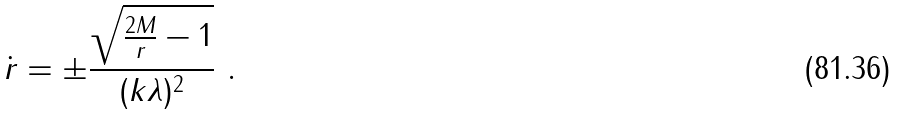Convert formula to latex. <formula><loc_0><loc_0><loc_500><loc_500>\dot { r } = \pm \frac { \sqrt { \frac { 2 M } { r } - 1 } } { ( k \lambda ) ^ { 2 } } \ .</formula> 